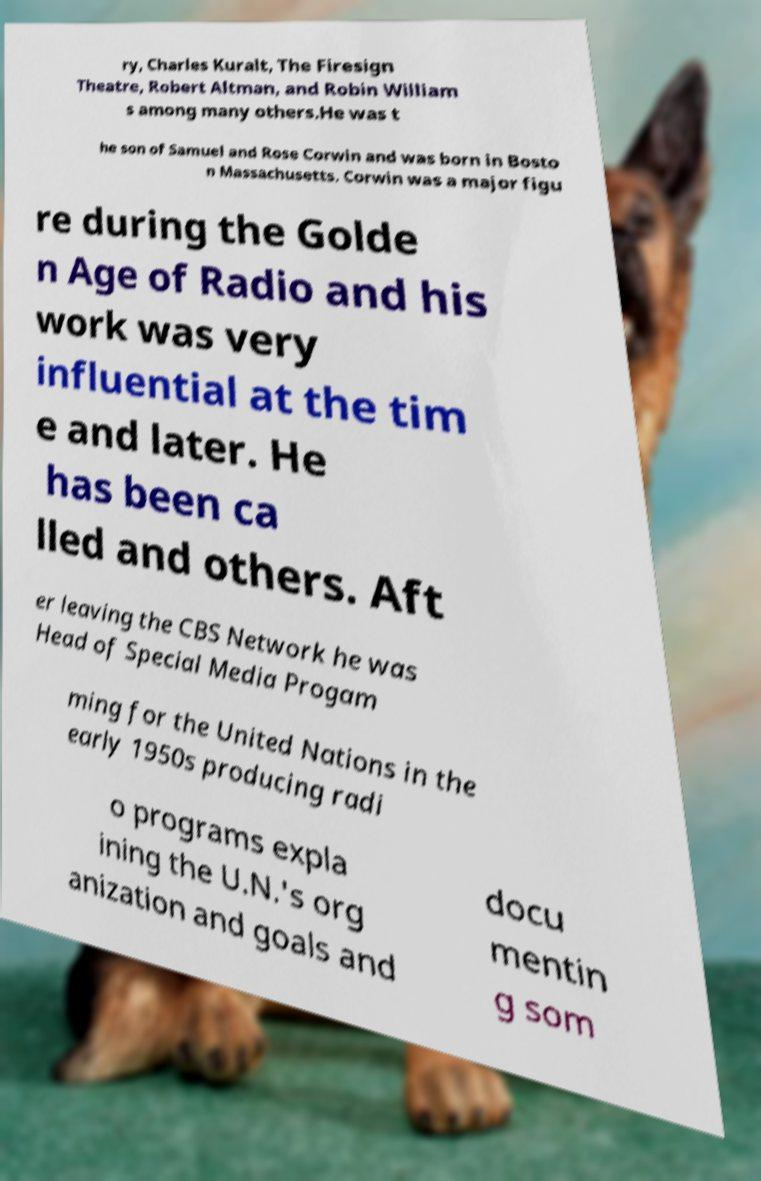Can you read and provide the text displayed in the image?This photo seems to have some interesting text. Can you extract and type it out for me? ry, Charles Kuralt, The Firesign Theatre, Robert Altman, and Robin William s among many others.He was t he son of Samuel and Rose Corwin and was born in Bosto n Massachusetts. Corwin was a major figu re during the Golde n Age of Radio and his work was very influential at the tim e and later. He has been ca lled and others. Aft er leaving the CBS Network he was Head of Special Media Progam ming for the United Nations in the early 1950s producing radi o programs expla ining the U.N.'s org anization and goals and docu mentin g som 